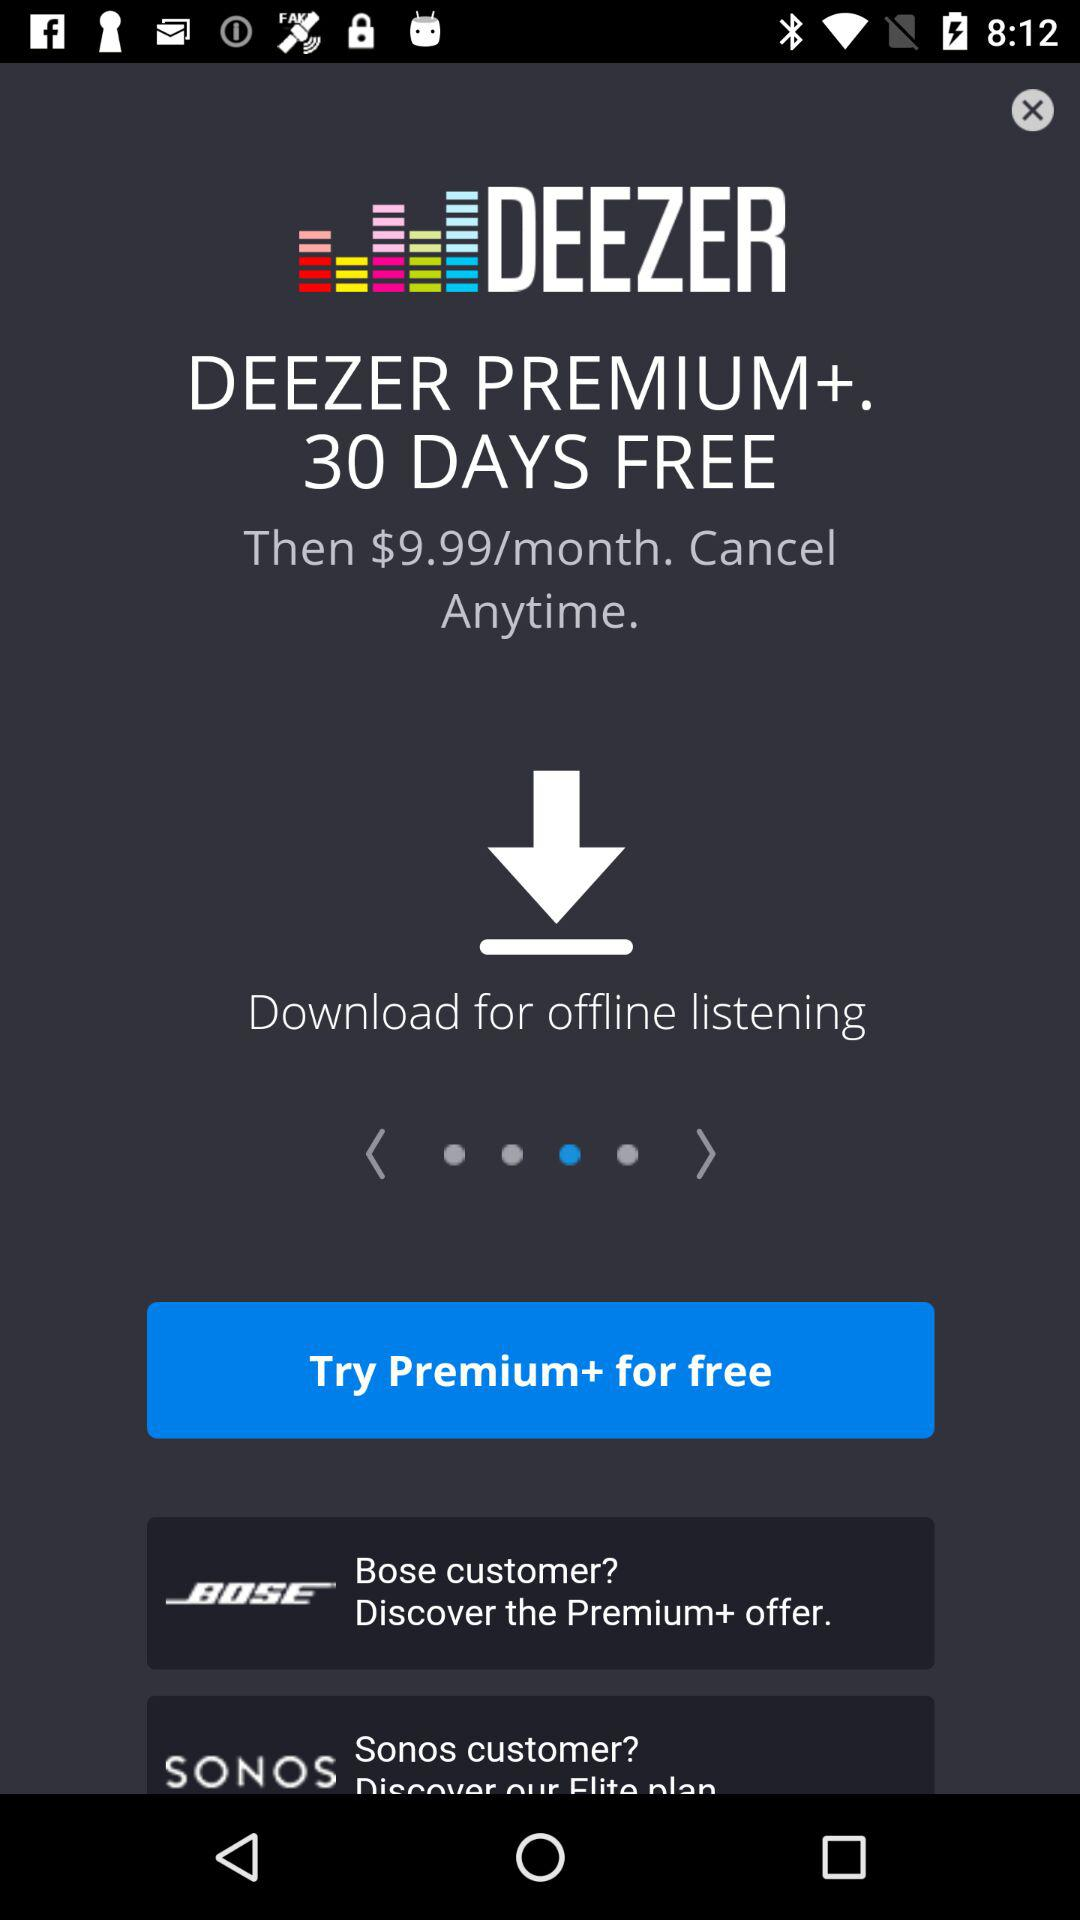How much is Deezer Premium+ after the free trial?
Answer the question using a single word or phrase. $9.99/month 